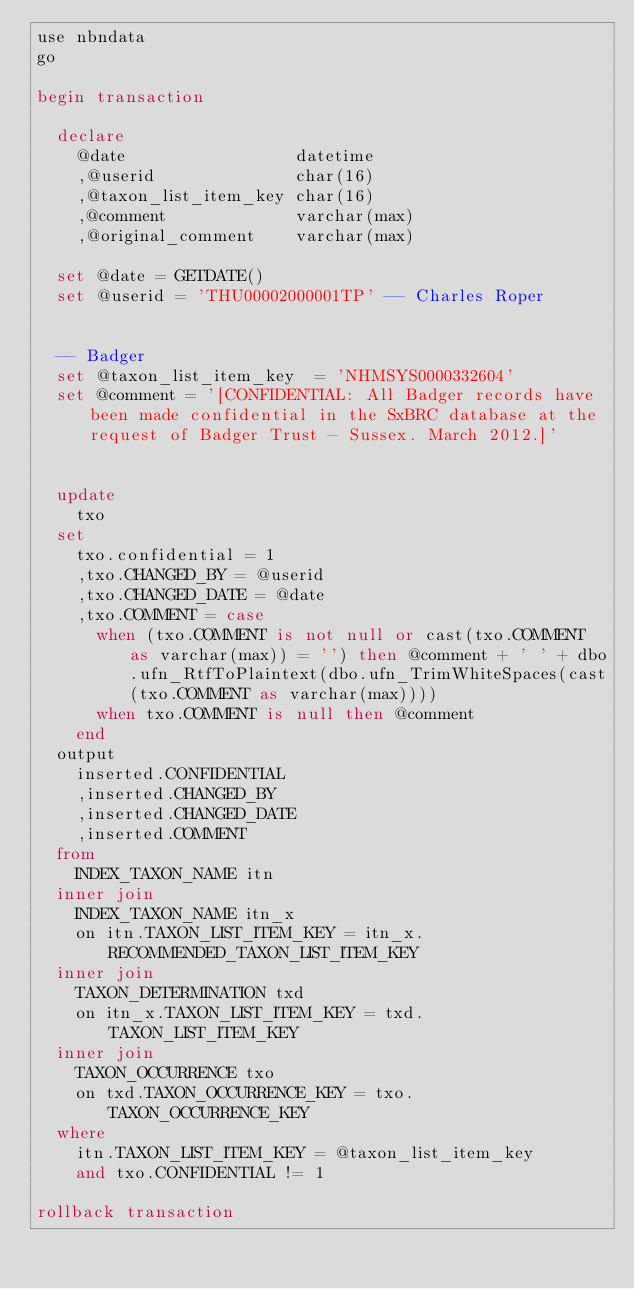Convert code to text. <code><loc_0><loc_0><loc_500><loc_500><_SQL_>use nbndata
go

begin transaction

	declare
		@date									datetime
		,@userid							char(16)
		,@taxon_list_item_key	char(16)
		,@comment							varchar(max)
		,@original_comment		varchar(max)

	set @date = GETDATE()
	set @userid	= 'THU00002000001TP' -- Charles Roper


	-- Badger
	set @taxon_list_item_key	= 'NHMSYS0000332604'
	set @comment = '[CONFIDENTIAL: All Badger records have been made confidential in the SxBRC database at the request of Badger Trust - Sussex. March 2012.]'


	update
		txo
	set
		txo.confidential = 1
		,txo.CHANGED_BY = @userid
		,txo.CHANGED_DATE = @date
		,txo.COMMENT = case
			when (txo.COMMENT is not null or cast(txo.COMMENT as varchar(max)) = '') then @comment + ' ' + dbo.ufn_RtfToPlaintext(dbo.ufn_TrimWhiteSpaces(cast(txo.COMMENT as varchar(max))))
			when txo.COMMENT is null then @comment
		end
	output
		inserted.CONFIDENTIAL
		,inserted.CHANGED_BY
		,inserted.CHANGED_DATE
		,inserted.COMMENT
	from
		INDEX_TAXON_NAME itn
	inner join
		INDEX_TAXON_NAME itn_x
		on itn.TAXON_LIST_ITEM_KEY = itn_x.RECOMMENDED_TAXON_LIST_ITEM_KEY
	inner join
		TAXON_DETERMINATION txd
		on itn_x.TAXON_LIST_ITEM_KEY = txd.TAXON_LIST_ITEM_KEY
	inner join
		TAXON_OCCURRENCE txo
		on txd.TAXON_OCCURRENCE_KEY = txo.TAXON_OCCURRENCE_KEY
	where
		itn.TAXON_LIST_ITEM_KEY = @taxon_list_item_key
		and txo.CONFIDENTIAL != 1

rollback transaction
</code> 